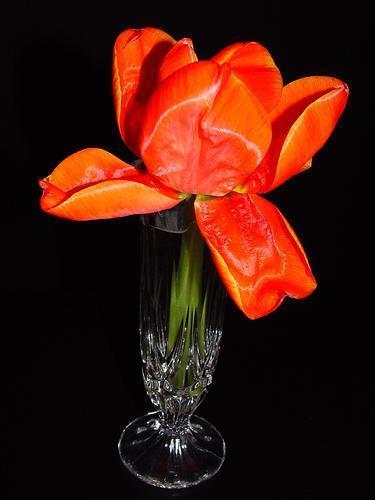How many vases are visible?
Give a very brief answer. 1. 